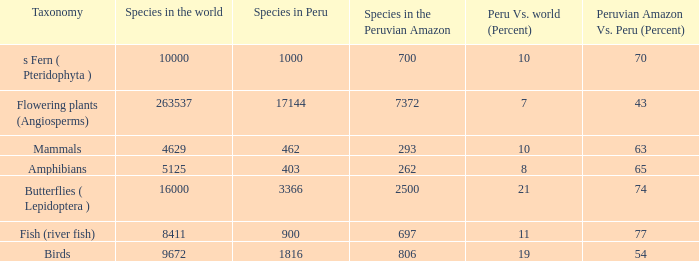What's the total number of species in the peruvian amazon with 8411 species in the world  1.0. 